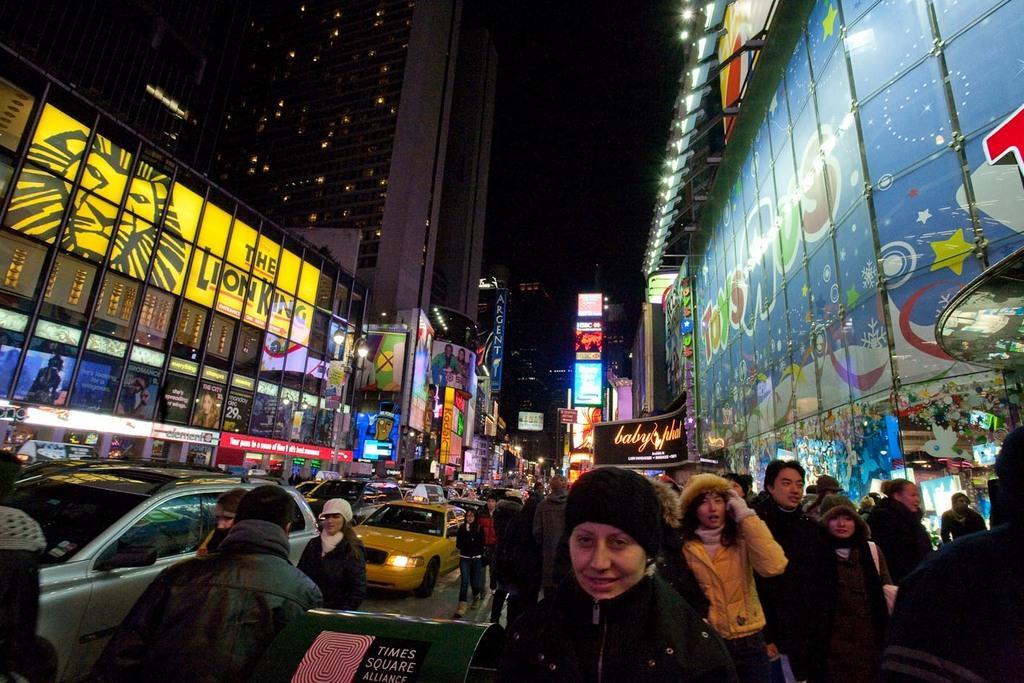Can you describe this image briefly? In the center of the image we can see persons and vehicles on the road. On the right and left side of the image we can see buildings and lights. In the background there is a sky. 